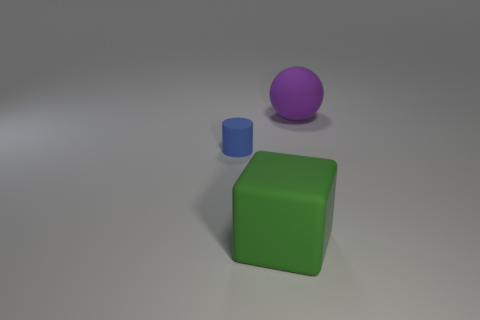Subtract all cubes. How many objects are left? 2 Subtract 1 balls. How many balls are left? 0 Subtract all gray cylinders. Subtract all red blocks. How many cylinders are left? 1 Subtract all blue things. Subtract all small brown matte cubes. How many objects are left? 2 Add 3 small things. How many small things are left? 4 Add 3 small purple metallic spheres. How many small purple metallic spheres exist? 3 Add 3 big purple matte objects. How many objects exist? 6 Subtract 0 blue cubes. How many objects are left? 3 